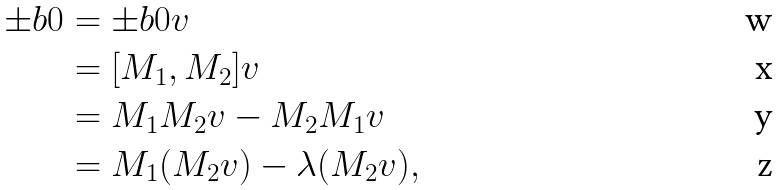<formula> <loc_0><loc_0><loc_500><loc_500>\pm b { 0 } & = \pm b { 0 } v \\ & = [ M _ { 1 } , M _ { 2 } ] v \\ & = M _ { 1 } M _ { 2 } v - M _ { 2 } M _ { 1 } v \\ & = M _ { 1 } ( M _ { 2 } v ) - \lambda ( M _ { 2 } v ) ,</formula> 